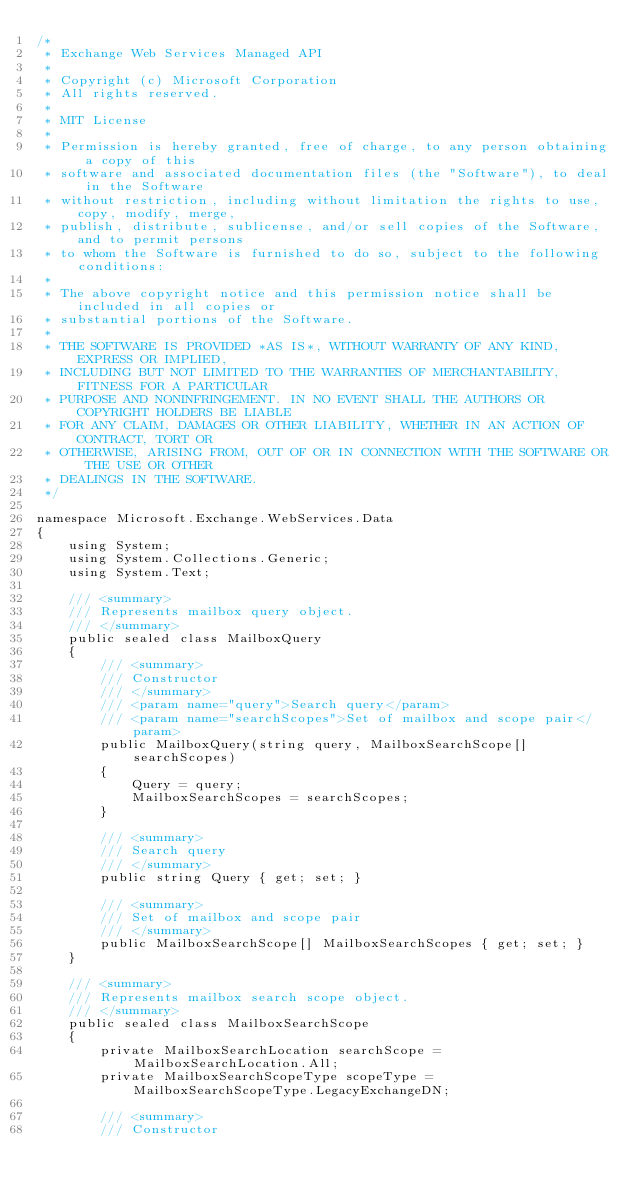<code> <loc_0><loc_0><loc_500><loc_500><_C#_>/*
 * Exchange Web Services Managed API
 *
 * Copyright (c) Microsoft Corporation
 * All rights reserved.
 *
 * MIT License
 *
 * Permission is hereby granted, free of charge, to any person obtaining a copy of this
 * software and associated documentation files (the "Software"), to deal in the Software
 * without restriction, including without limitation the rights to use, copy, modify, merge,
 * publish, distribute, sublicense, and/or sell copies of the Software, and to permit persons
 * to whom the Software is furnished to do so, subject to the following conditions:
 *
 * The above copyright notice and this permission notice shall be included in all copies or
 * substantial portions of the Software.
 *
 * THE SOFTWARE IS PROVIDED *AS IS*, WITHOUT WARRANTY OF ANY KIND, EXPRESS OR IMPLIED,
 * INCLUDING BUT NOT LIMITED TO THE WARRANTIES OF MERCHANTABILITY, FITNESS FOR A PARTICULAR
 * PURPOSE AND NONINFRINGEMENT. IN NO EVENT SHALL THE AUTHORS OR COPYRIGHT HOLDERS BE LIABLE
 * FOR ANY CLAIM, DAMAGES OR OTHER LIABILITY, WHETHER IN AN ACTION OF CONTRACT, TORT OR
 * OTHERWISE, ARISING FROM, OUT OF OR IN CONNECTION WITH THE SOFTWARE OR THE USE OR OTHER
 * DEALINGS IN THE SOFTWARE.
 */

namespace Microsoft.Exchange.WebServices.Data
{
    using System;
    using System.Collections.Generic;
    using System.Text;

    /// <summary>
    /// Represents mailbox query object.
    /// </summary>
    public sealed class MailboxQuery
    {
        /// <summary>
        /// Constructor
        /// </summary>
        /// <param name="query">Search query</param>
        /// <param name="searchScopes">Set of mailbox and scope pair</param>
        public MailboxQuery(string query, MailboxSearchScope[] searchScopes)
        {
            Query = query;
            MailboxSearchScopes = searchScopes;
        }

        /// <summary>
        /// Search query
        /// </summary>
        public string Query { get; set; }

        /// <summary>
        /// Set of mailbox and scope pair
        /// </summary>
        public MailboxSearchScope[] MailboxSearchScopes { get; set; }
    }

    /// <summary>
    /// Represents mailbox search scope object.
    /// </summary>
    public sealed class MailboxSearchScope
    {
        private MailboxSearchLocation searchScope = MailboxSearchLocation.All;
        private MailboxSearchScopeType scopeType = MailboxSearchScopeType.LegacyExchangeDN;

        /// <summary>
        /// Constructor</code> 